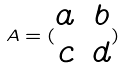<formula> <loc_0><loc_0><loc_500><loc_500>A = ( \begin{matrix} a & b \\ c & d \\ \end{matrix} )</formula> 